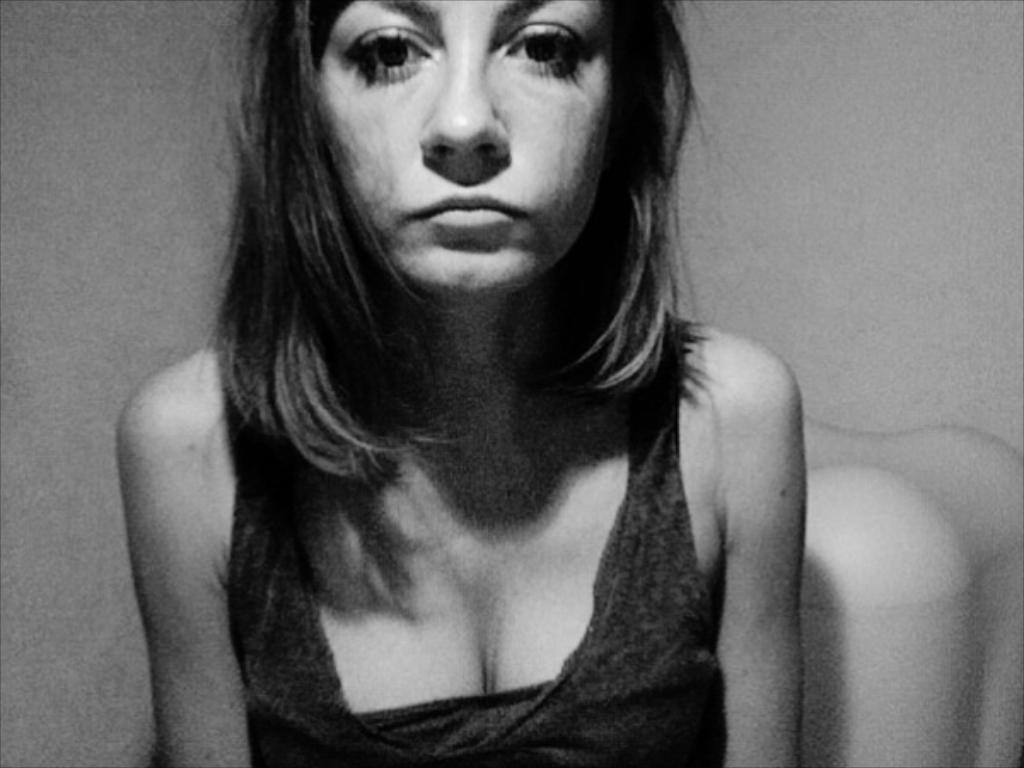In one or two sentences, can you explain what this image depicts? In the picture there is a woman, behind the woman there may be a wall. 